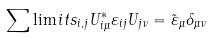Convert formula to latex. <formula><loc_0><loc_0><loc_500><loc_500>\sum \lim i t s _ { i , j } { U _ { i \mu } ^ { \ast } \varepsilon _ { i j } U _ { j \nu } } = \tilde { \varepsilon } _ { \mu } \delta _ { \mu \nu }</formula> 